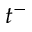Convert formula to latex. <formula><loc_0><loc_0><loc_500><loc_500>t ^ { - }</formula> 